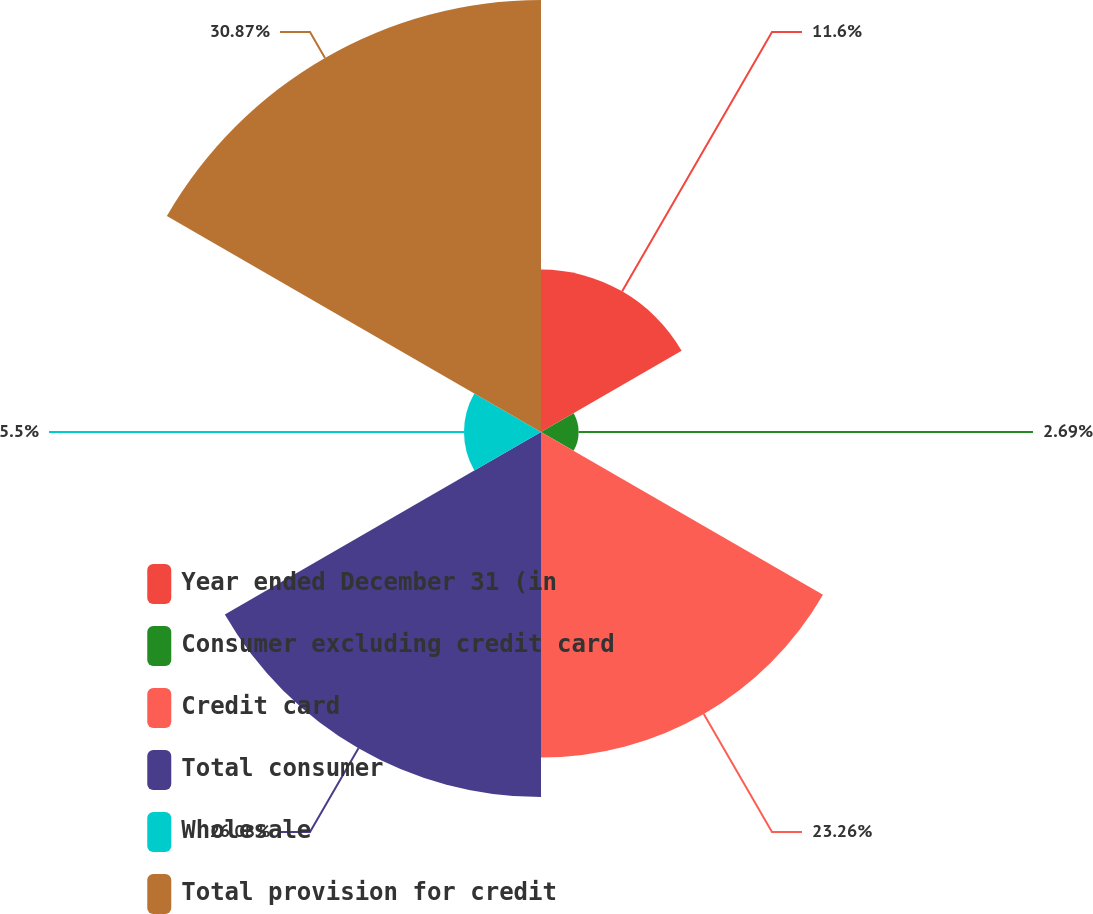Convert chart to OTSL. <chart><loc_0><loc_0><loc_500><loc_500><pie_chart><fcel>Year ended December 31 (in<fcel>Consumer excluding credit card<fcel>Credit card<fcel>Total consumer<fcel>Wholesale<fcel>Total provision for credit<nl><fcel>11.6%<fcel>2.69%<fcel>23.26%<fcel>26.08%<fcel>5.5%<fcel>30.86%<nl></chart> 